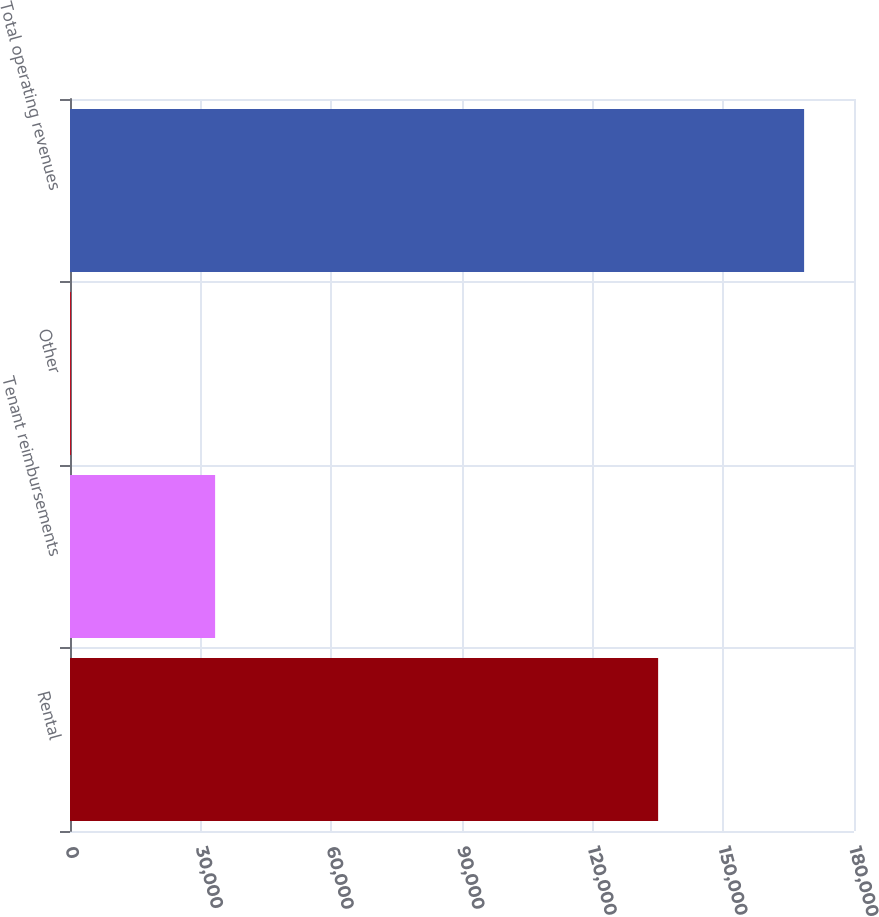Convert chart to OTSL. <chart><loc_0><loc_0><loc_500><loc_500><bar_chart><fcel>Rental<fcel>Tenant reimbursements<fcel>Other<fcel>Total operating revenues<nl><fcel>135031<fcel>33317<fcel>197<fcel>168545<nl></chart> 